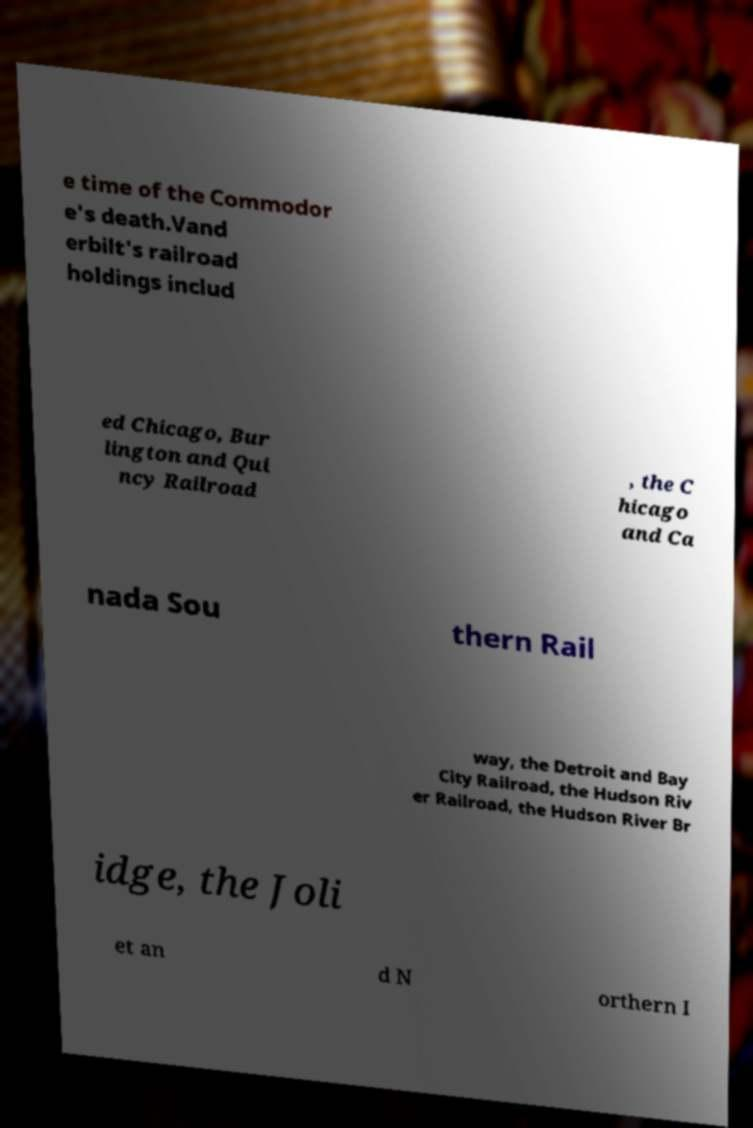For documentation purposes, I need the text within this image transcribed. Could you provide that? e time of the Commodor e's death.Vand erbilt's railroad holdings includ ed Chicago, Bur lington and Qui ncy Railroad , the C hicago and Ca nada Sou thern Rail way, the Detroit and Bay City Railroad, the Hudson Riv er Railroad, the Hudson River Br idge, the Joli et an d N orthern I 